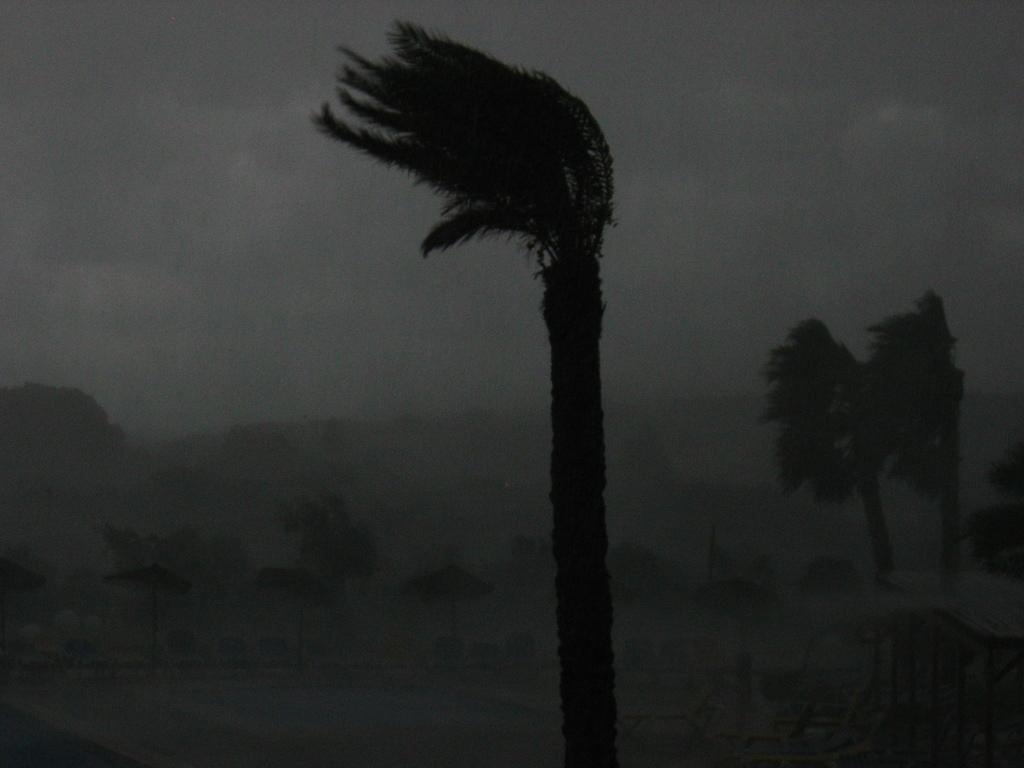What is the main feature in the image? There is a swimming pool in the image. What type of furniture is present in the image? There are chairs in the image. What provides shade in the image? There are umbrellas in the image. What structure is visible above the swimming pool? There is a roof with poles in the image. What type of vegetation is present in the image? There is a group of trees in the image. How would you describe the sky in the image? The sky is visible in the image and appears cloudy. How many mice can be seen climbing on the roof in the image? There are no mice present in the image; it features a roof with poles and other elements mentioned in the facts. 